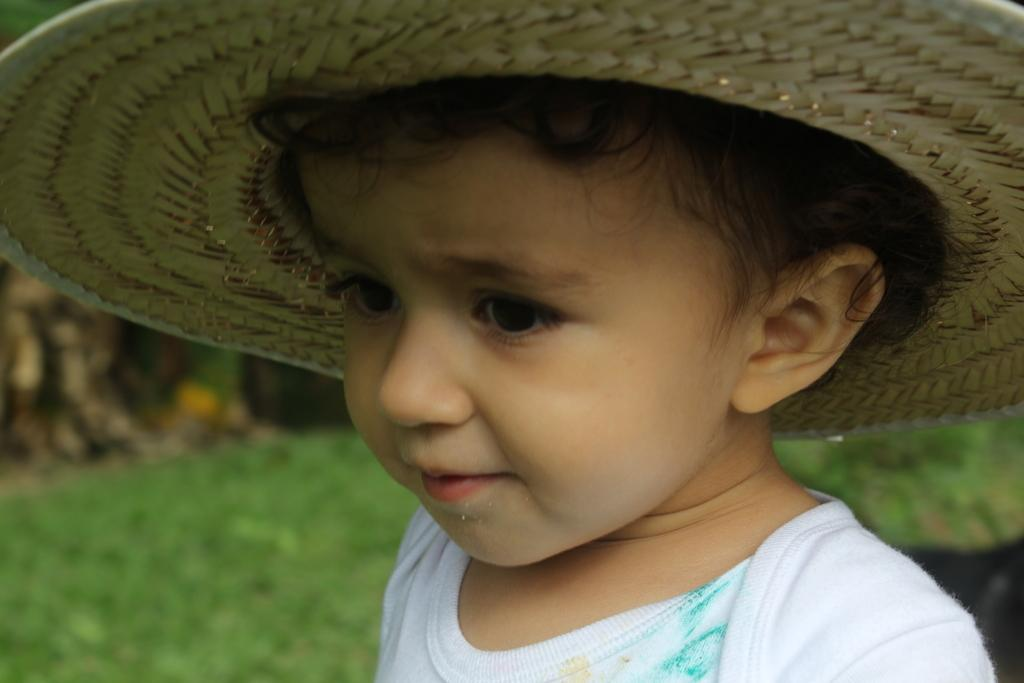Who is present in the image? There is a boy in the image. What is the boy wearing on his head? The boy is wearing a hat. What type of surface can be seen in the background of the image? There is grass on the ground in the background of the image. How many rabbits can be seen in the image? There are no rabbits present in the image. 